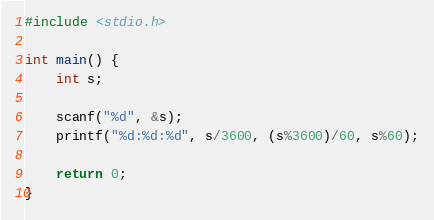Convert code to text. <code><loc_0><loc_0><loc_500><loc_500><_C_>#include <stdio.h>

int main() {
    int s;
    
    scanf("%d", &s);
    printf("%d:%d:%d", s/3600, (s%3600)/60, s%60);
    
    return 0;
}
</code> 